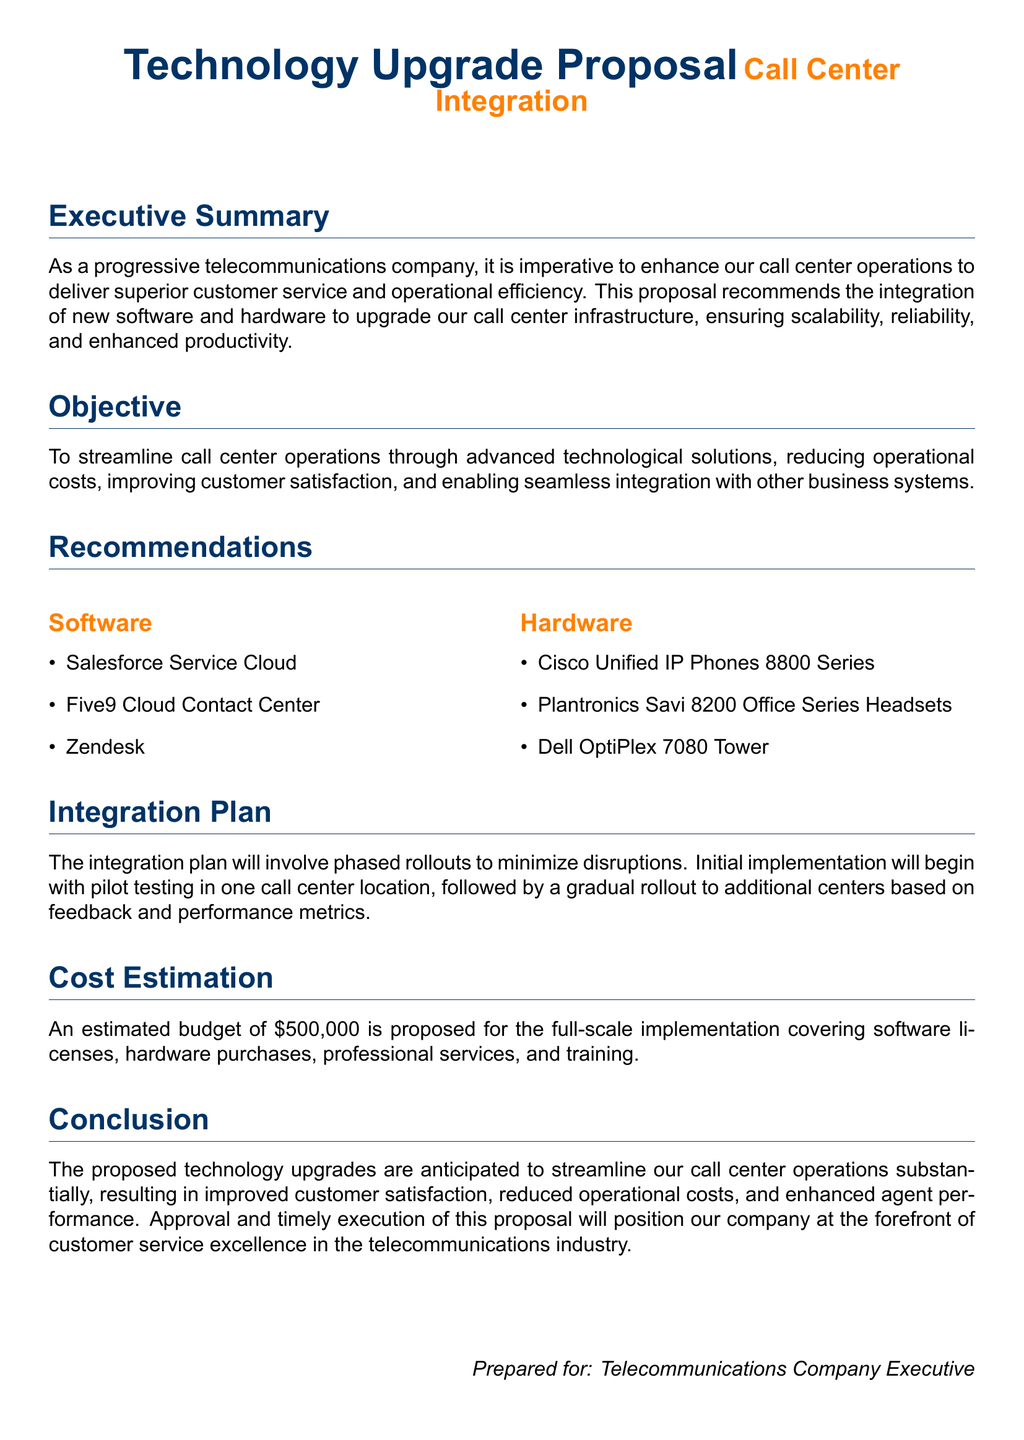What is the title of the proposal? The title is prominently displayed at the top of the document as part of the heading.
Answer: Technology Upgrade Proposal What is the estimated budget for implementation? The budget is explicitly mentioned in the Cost Estimation section.
Answer: $500,000 Which software is recommended for call center integration? The document lists several software options under the Recommendations section.
Answer: Salesforce Service Cloud What type of hardware is suggested for the call center? The document provides examples of hardware in the Recommendations section.
Answer: Cisco Unified IP Phones 8800 Series What is the objective of the proposal? The objective is clearly stated at the beginning of the document.
Answer: To streamline call center operations How will the integration plan be executed? The execution method of the integration plan is detailed in its respective section.
Answer: Phased rollouts What is anticipated as a result of the proposed upgrades? The conclusion summarizes the expected outcomes of the proposal.
Answer: Improved customer satisfaction What is the first step in the integration plan? The document outlines the initial actions in the Integration Plan section.
Answer: Pilot testing Who is this proposal prepared for? The intended audience for the proposal is identified in the footer.
Answer: Telecommunications Company Executive 